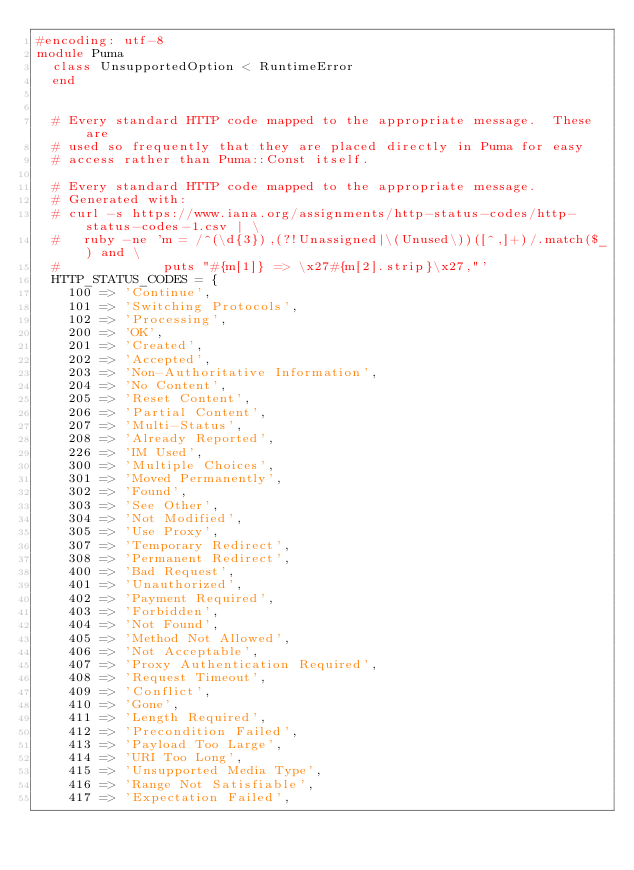<code> <loc_0><loc_0><loc_500><loc_500><_Ruby_>#encoding: utf-8
module Puma
  class UnsupportedOption < RuntimeError
  end


  # Every standard HTTP code mapped to the appropriate message.  These are
  # used so frequently that they are placed directly in Puma for easy
  # access rather than Puma::Const itself.

  # Every standard HTTP code mapped to the appropriate message.
  # Generated with:
  # curl -s https://www.iana.org/assignments/http-status-codes/http-status-codes-1.csv | \
  #   ruby -ne 'm = /^(\d{3}),(?!Unassigned|\(Unused\))([^,]+)/.match($_) and \
  #             puts "#{m[1]} => \x27#{m[2].strip}\x27,"'
  HTTP_STATUS_CODES = {
    100 => 'Continue',
    101 => 'Switching Protocols',
    102 => 'Processing',
    200 => 'OK',
    201 => 'Created',
    202 => 'Accepted',
    203 => 'Non-Authoritative Information',
    204 => 'No Content',
    205 => 'Reset Content',
    206 => 'Partial Content',
    207 => 'Multi-Status',
    208 => 'Already Reported',
    226 => 'IM Used',
    300 => 'Multiple Choices',
    301 => 'Moved Permanently',
    302 => 'Found',
    303 => 'See Other',
    304 => 'Not Modified',
    305 => 'Use Proxy',
    307 => 'Temporary Redirect',
    308 => 'Permanent Redirect',
    400 => 'Bad Request',
    401 => 'Unauthorized',
    402 => 'Payment Required',
    403 => 'Forbidden',
    404 => 'Not Found',
    405 => 'Method Not Allowed',
    406 => 'Not Acceptable',
    407 => 'Proxy Authentication Required',
    408 => 'Request Timeout',
    409 => 'Conflict',
    410 => 'Gone',
    411 => 'Length Required',
    412 => 'Precondition Failed',
    413 => 'Payload Too Large',
    414 => 'URI Too Long',
    415 => 'Unsupported Media Type',
    416 => 'Range Not Satisfiable',
    417 => 'Expectation Failed',</code> 